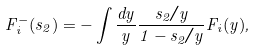Convert formula to latex. <formula><loc_0><loc_0><loc_500><loc_500>F ^ { - } _ { i } ( s _ { 2 } ) = - \int \frac { d y } { y } \frac { s _ { 2 } / y } { 1 - s _ { 2 } / y } F _ { i } ( y ) ,</formula> 